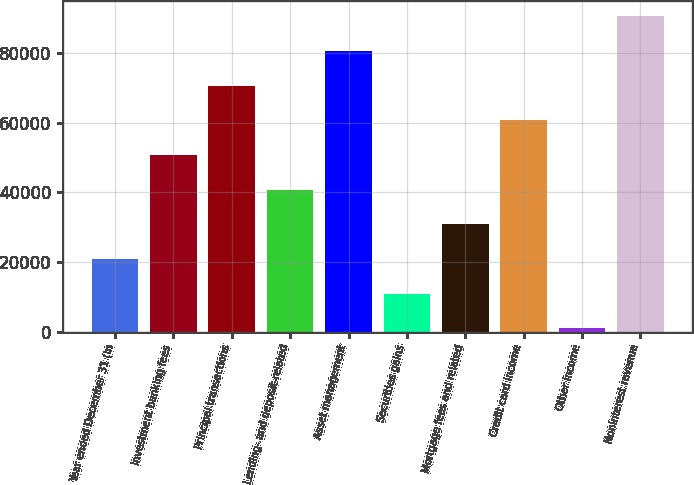Convert chart to OTSL. <chart><loc_0><loc_0><loc_500><loc_500><bar_chart><fcel>Year ended December 31 (in<fcel>Investment banking fees<fcel>Principal transactions<fcel>Lending- and deposit-related<fcel>Asset management<fcel>Securities gains<fcel>Mortgage fees and related<fcel>Credit card income<fcel>Other income<fcel>Noninterest revenue<nl><fcel>20819.6<fcel>50675<fcel>70578.6<fcel>40723.2<fcel>80530.4<fcel>10867.8<fcel>30771.4<fcel>60626.8<fcel>916<fcel>90482.2<nl></chart> 